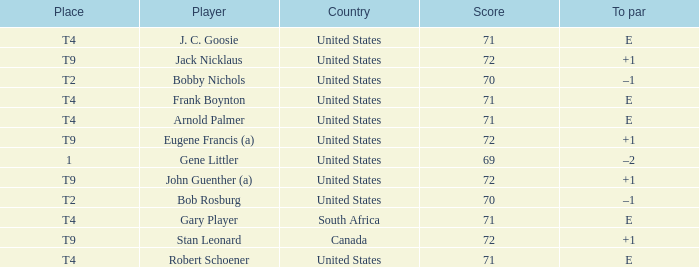What is Place, when Score is less than 70? 1.0. 